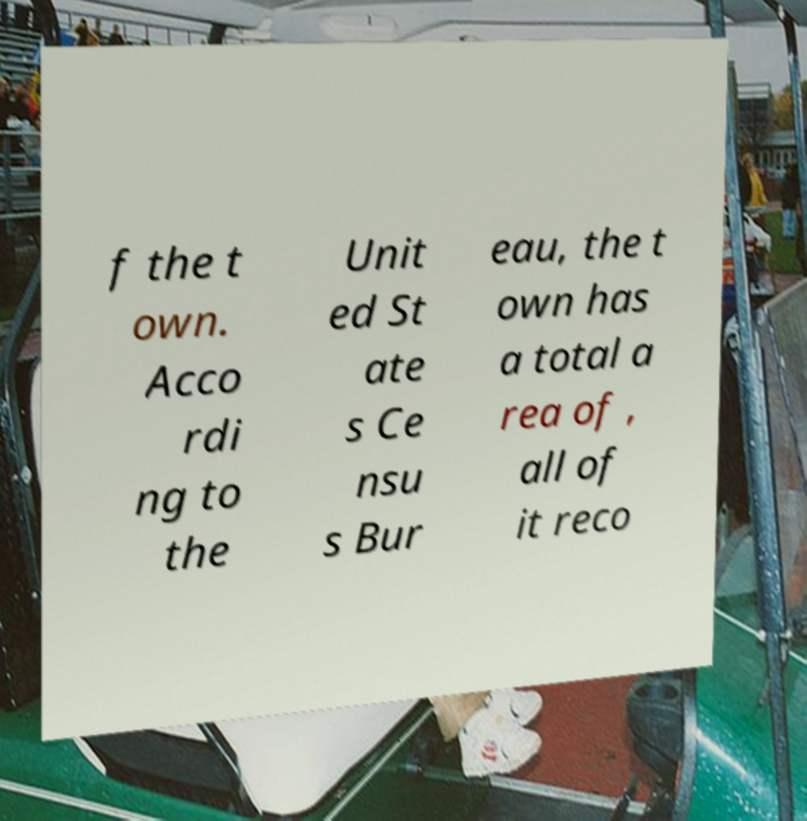Could you assist in decoding the text presented in this image and type it out clearly? f the t own. Acco rdi ng to the Unit ed St ate s Ce nsu s Bur eau, the t own has a total a rea of , all of it reco 